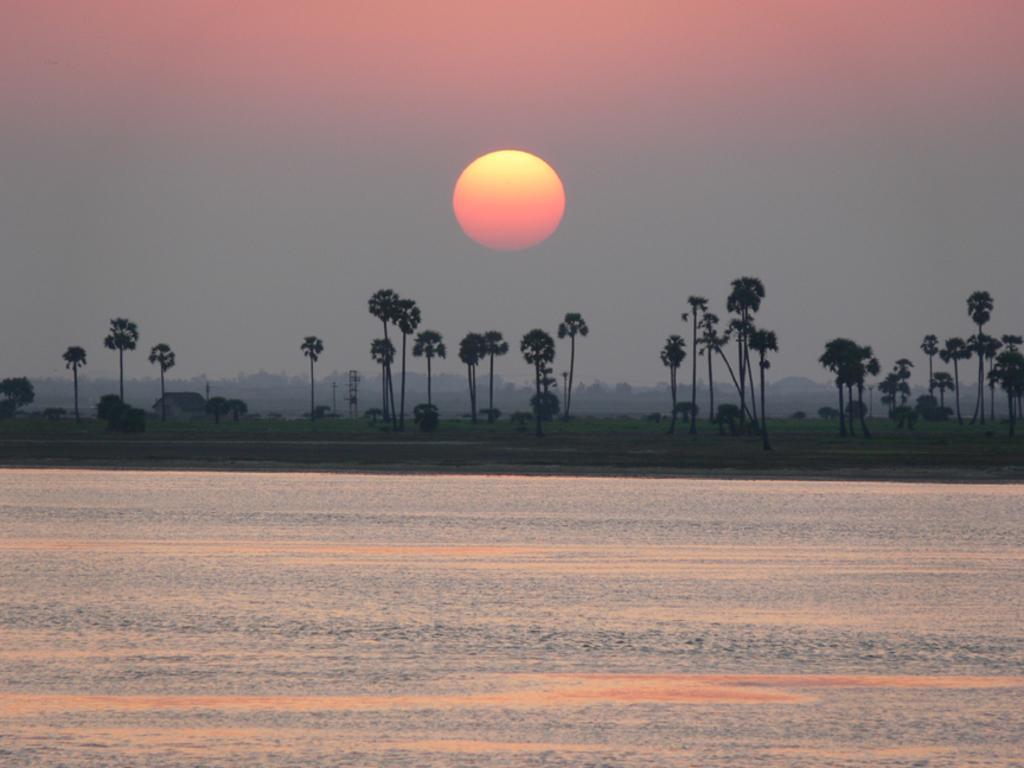Please provide a concise description of this image. At the bottom of the image we can see water. In the background we can see trees, grass, sky and sun. 